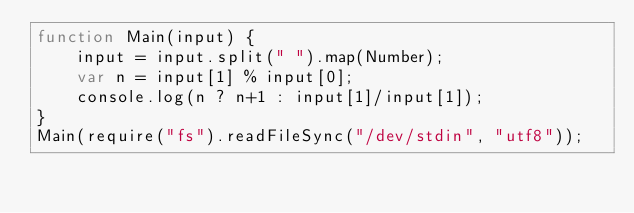Convert code to text. <code><loc_0><loc_0><loc_500><loc_500><_JavaScript_>function Main(input) {
    input = input.split(" ").map(Number);
  	var n = input[1] % input[0];
  	console.log(n ? n+1 : input[1]/input[1]);
}
Main(require("fs").readFileSync("/dev/stdin", "utf8"));
</code> 